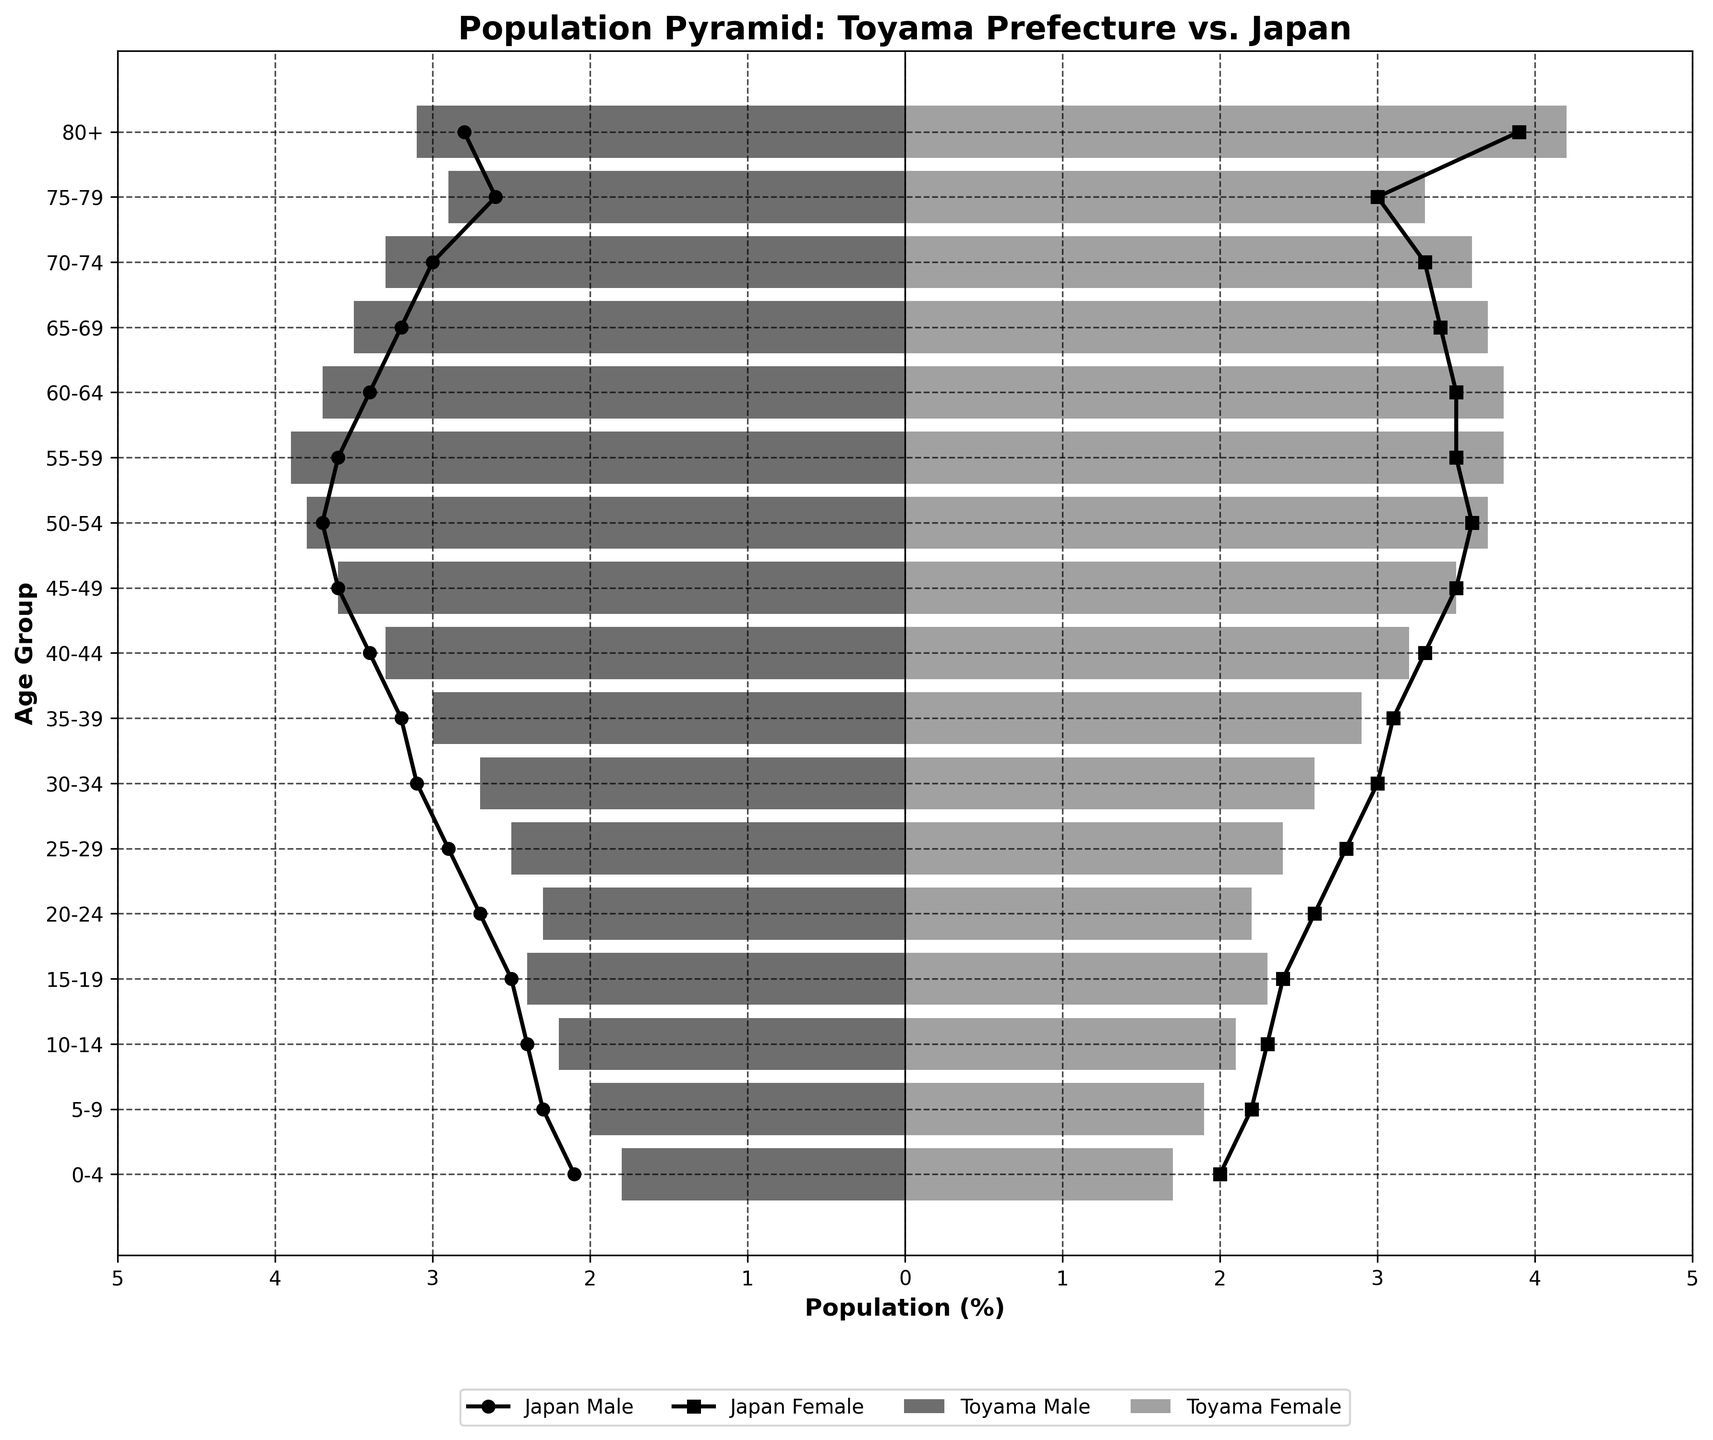What is the title of the figure? The title is usually placed prominently at the top of the figure. By looking at the figure, you can see the title "Population Pyramid: Toyama Prefecture vs. Japan".
Answer: Population Pyramid: Toyama Prefecture vs. Japan How are the age groups displayed in the figure? Age groups are displayed vertically on the Y-axis. Each horizontal bar or line represents a different age group, from 0-4 years at the bottom to 80+ years at the top.
Answer: Vertically on the Y-axis What color is used for Toyama Male population bars? By examining the bars on the left side for Toyama Male in the figure, they are shaded in a dark gray color.
Answer: Dark gray Which age group has the highest percentage of females in Toyama? By comparing the lengths of the bars for Toyama Female population, the age group 80+ has the highest percentage with approximately 4.2%.
Answer: Age group 80+ How does the population distribution of Toyama Females aged 20-24 compare to the national average? Look at the right side of the age group 20-24: The bar for Toyama Female is slightly shorter than the line for Japan Female. Thus, Toyama has a smaller percentage of females in this age group than the national average.
Answer: Smaller Which gender group in Toyama has the highest population percentage in the 55-59 age group? For the age group 55-59, compare the lengths of the bars for Toyama Male and Toyama Female. The Toyama Male bar is slightly longer, indicating a higher percentage of males.
Answer: Toyama Male What is the difference between the percentages of Japan Male and Japan Female in the 70-74 age group? Using the figure, find the presence of Japan Male and Japan Female markers in the 70-74 age group. The difference is calculated as 3.0% (female) - 3.3% (male) = -0.3%.
Answer: -0.3% Which age group has the smallest percentage difference between Toyama Male and Toyama Female populations? Look at each age group and compare the lengths of Toyama Male and Toyama Female bars. The age group 0-4 has the smallest percentage difference, with only a 0.1% difference between 1.8% (male) and 1.7% (female).
Answer: Age group 0-4 In which age group does the Toyama population significantly exceed the national average for males? Look at the lengths and lines for Toyama Male and Japan Male across all age groups. The age group 55-59 shows Toyama Male exceeding Japan Male by approximately 0.3% (3.9% vs. 3.6%).
Answer: Age group 55-59 How does the population pyramid indicate aging trends in Toyama compared to Japan? By examining the pyramid, we notice that the older age groups (65+) have larger bars for Toyama compared to the corresponding Japan markers, suggesting a higher proportion of elderly population in Toyama relative to Japan.
Answer: Higher proportion of elderly in Toyama 